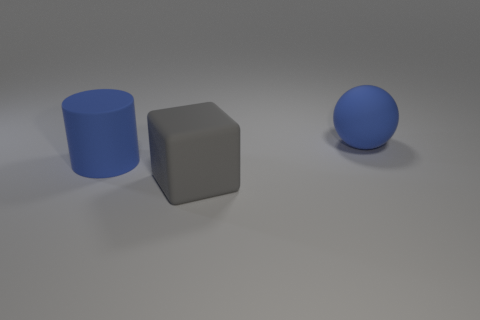How many blue rubber objects are the same size as the gray matte thing? 2 